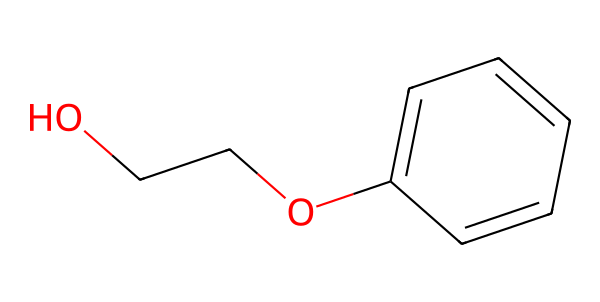What is the molecular formula of phenoxyethanol? The chemical structure can be analyzed to determine the number of each type of atom present. In the given SMILES, there are 8 carbons, 10 hydrogens, and 2 oxygens, leading us to the molecular formula C8H10O2.
Answer: C8H10O2 How many carbon atoms are present in phenoxyethanol? By examining the SMILES representation, we count the carbon atoms represented in the structure. There are a total of 8 carbon atoms.
Answer: 8 What type of functional groups are present in phenoxyethanol? The structure reveals the presence of both an ether (indicated by the presence of -O-) and a phenolic -OH group (indicated by the presence of a benzene ring with an -OH attached), which can be classified as functional groups.
Answer: ether and phenol Is phenoxyethanol a natural or synthetic compound? Phenoxyethanol is typically synthesized through chemical processes, indicating it is a synthetic compound rather than a naturally occurring one.
Answer: synthetic How many rings are present in the chemical structure of phenoxyethanol? Analyzing the structure, we see that it contains one aromatic ring (the benzene ring part of the molecule).
Answer: 1 What is the primary role of phenoxyethanol in cosmetic formulations? The chemical structure indicates that phenoxyethanol acts primarily as a preservative to inhibit microbial growth in cosmetic products.
Answer: preservative What is the boiling point range of phenoxyethanol? While not depicted directly in the SMILES, phenoxyethanol typically has a boiling point around 200°C based on empirical data, which can be inferred from its chemical properties.
Answer: 200°C 